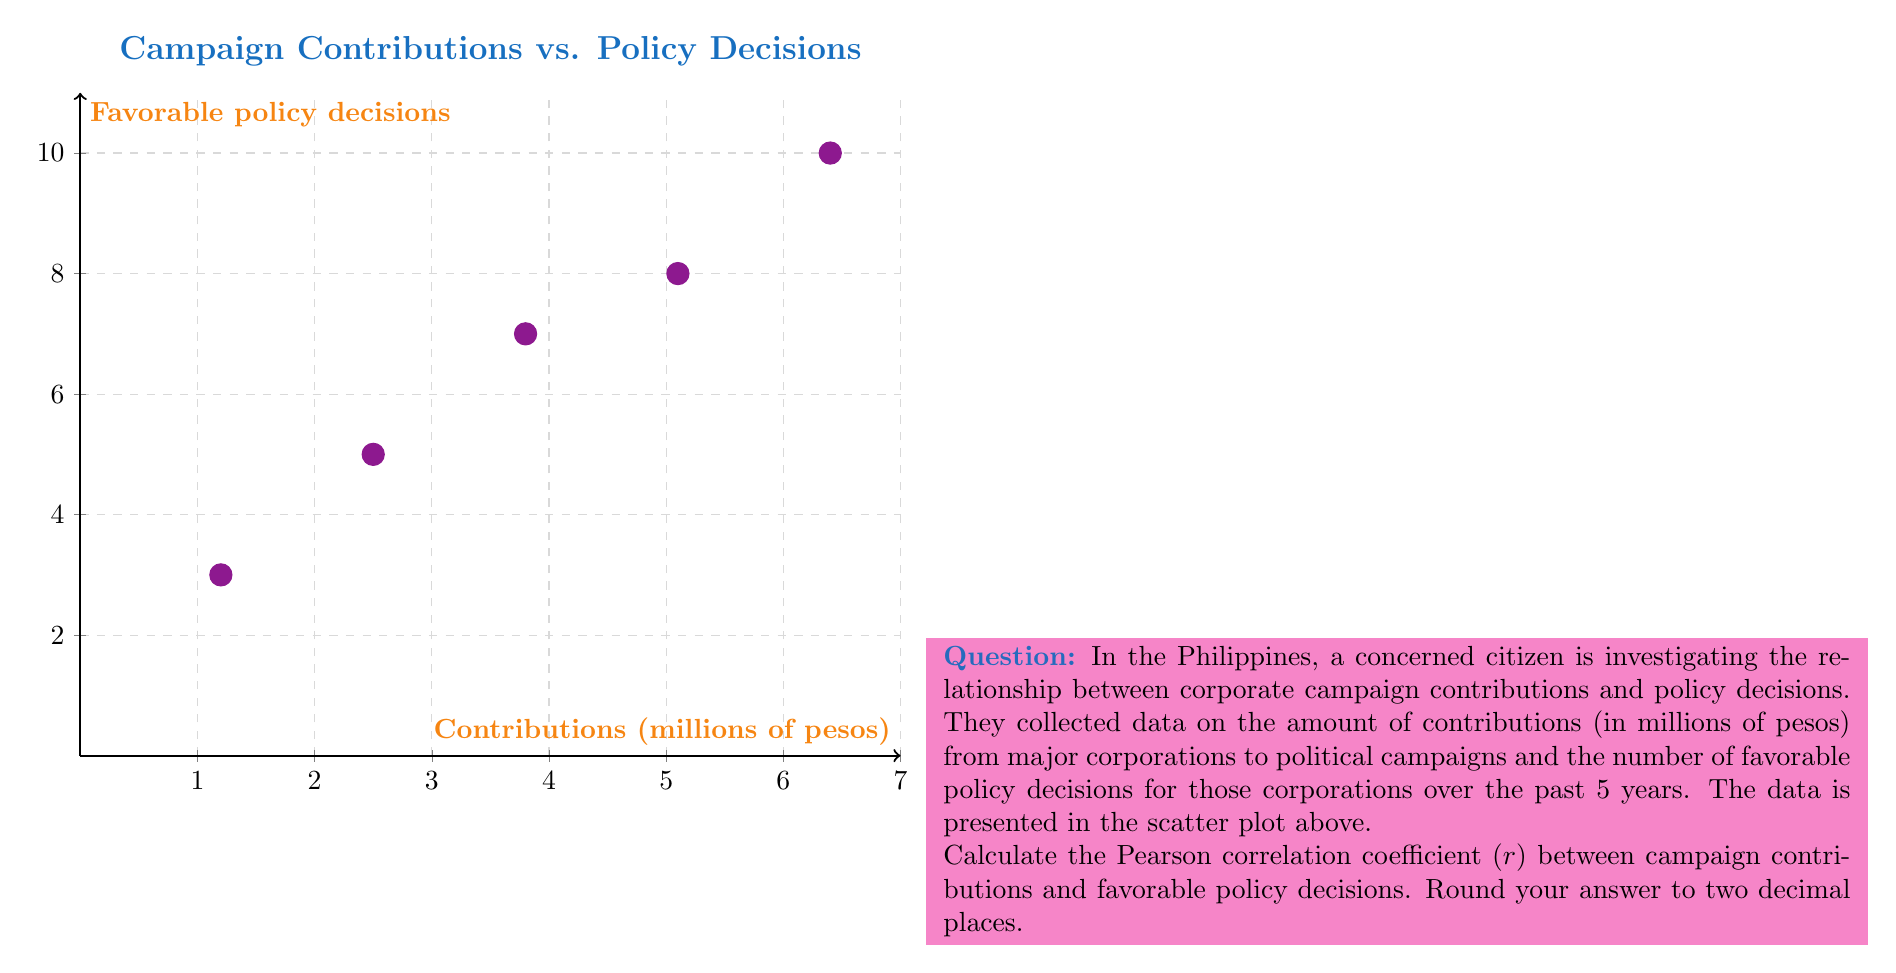Could you help me with this problem? To calculate the Pearson correlation coefficient (r), we'll follow these steps:

1. Calculate the means of x (contributions) and y (policy decisions):
   $\bar{x} = \frac{1.2 + 2.5 + 3.8 + 5.1 + 6.4}{5} = 3.8$
   $\bar{y} = \frac{3 + 5 + 7 + 8 + 10}{5} = 6.6$

2. Calculate the differences from the mean for each x and y value:
   x - $\bar{x}$: -2.6, -1.3, 0, 1.3, 2.6
   y - $\bar{y}$: -3.6, -1.6, 0.4, 1.4, 3.4

3. Calculate the products of these differences:
   (x - $\bar{x}$)(y - $\bar{y}$): 9.36, 2.08, 0, 1.82, 8.84

4. Sum these products:
   $\sum(x - \bar{x})(y - \bar{y}) = 22.1$

5. Calculate the squared differences:
   $(x - \bar{x})^2$: 6.76, 1.69, 0, 1.69, 6.76
   $(y - \bar{y})^2$: 12.96, 2.56, 0.16, 1.96, 11.56

6. Sum the squared differences:
   $\sum(x - \bar{x})^2 = 16.9$
   $\sum(y - \bar{y})^2 = 29.2$

7. Apply the Pearson correlation coefficient formula:
   $$r = \frac{\sum(x - \bar{x})(y - \bar{y})}{\sqrt{\sum(x - \bar{x})^2 \sum(y - \bar{y})^2}}$$

   $$r = \frac{22.1}{\sqrt{16.9 \times 29.2}} = \frac{22.1}{\sqrt{493.48}} = \frac{22.1}{22.215} = 0.9948$$

8. Round to two decimal places: 0.99
Answer: 0.99 